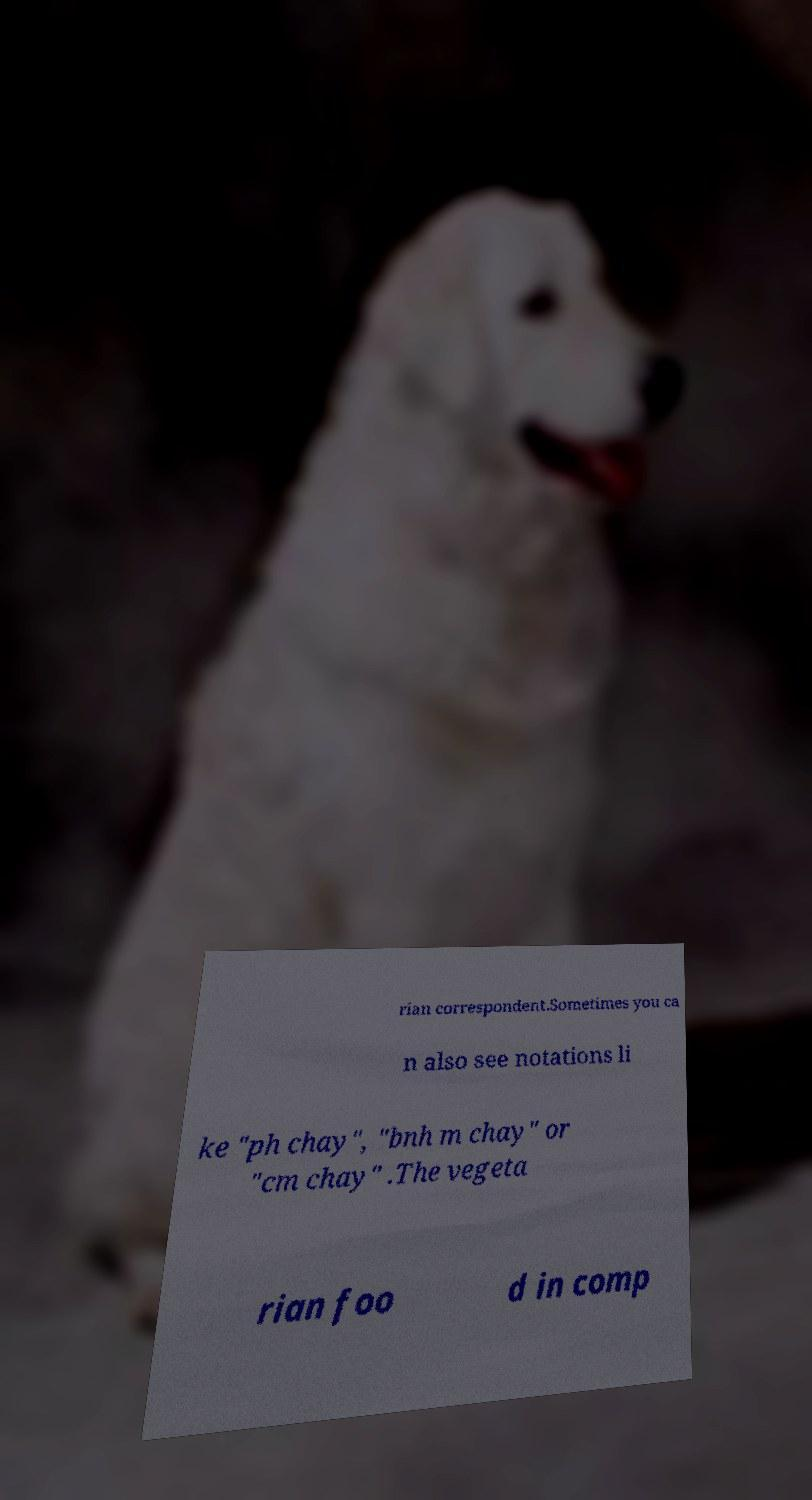Could you assist in decoding the text presented in this image and type it out clearly? rian correspondent.Sometimes you ca n also see notations li ke "ph chay", "bnh m chay" or "cm chay" .The vegeta rian foo d in comp 